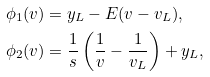<formula> <loc_0><loc_0><loc_500><loc_500>\phi _ { 1 } ( v ) & = y _ { L } - E ( v - v _ { L } ) , \\ \phi _ { 2 } ( v ) & = \frac { 1 } { s } \left ( \frac { 1 } { v } - \frac { 1 } { v _ { L } } \right ) + y _ { L } ,</formula> 